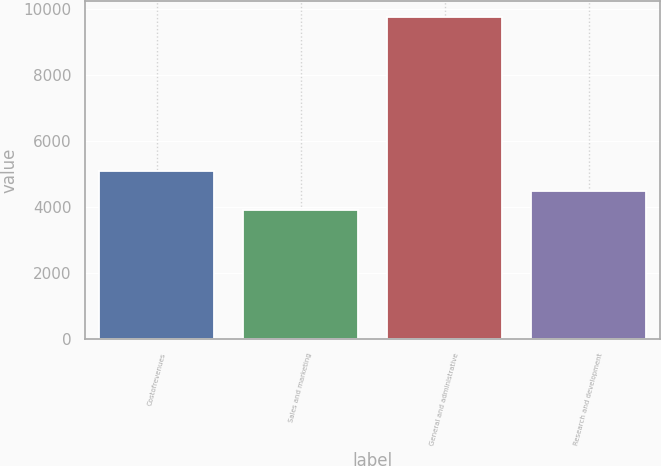Convert chart. <chart><loc_0><loc_0><loc_500><loc_500><bar_chart><fcel>Costofrevenues<fcel>Sales and marketing<fcel>General and administrative<fcel>Research and development<nl><fcel>5088.6<fcel>3920<fcel>9763<fcel>4504.3<nl></chart> 